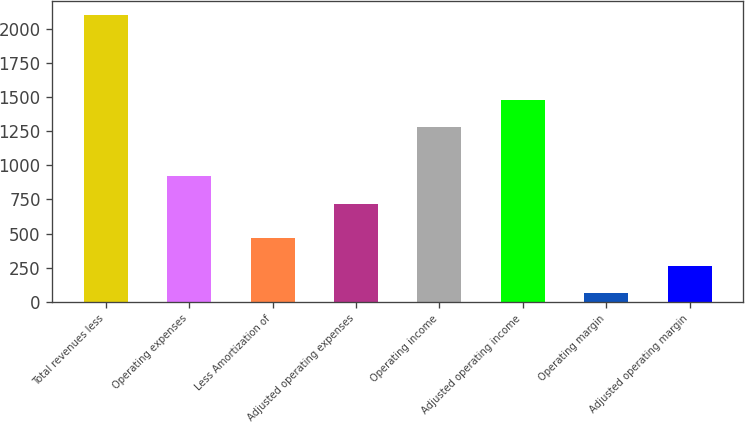<chart> <loc_0><loc_0><loc_500><loc_500><bar_chart><fcel>Total revenues less<fcel>Operating expenses<fcel>Less Amortization of<fcel>Adjusted operating expenses<fcel>Operating income<fcel>Adjusted operating income<fcel>Operating margin<fcel>Adjusted operating margin<nl><fcel>2102<fcel>919.1<fcel>469.2<fcel>715<fcel>1277<fcel>1481.1<fcel>61<fcel>265.1<nl></chart> 